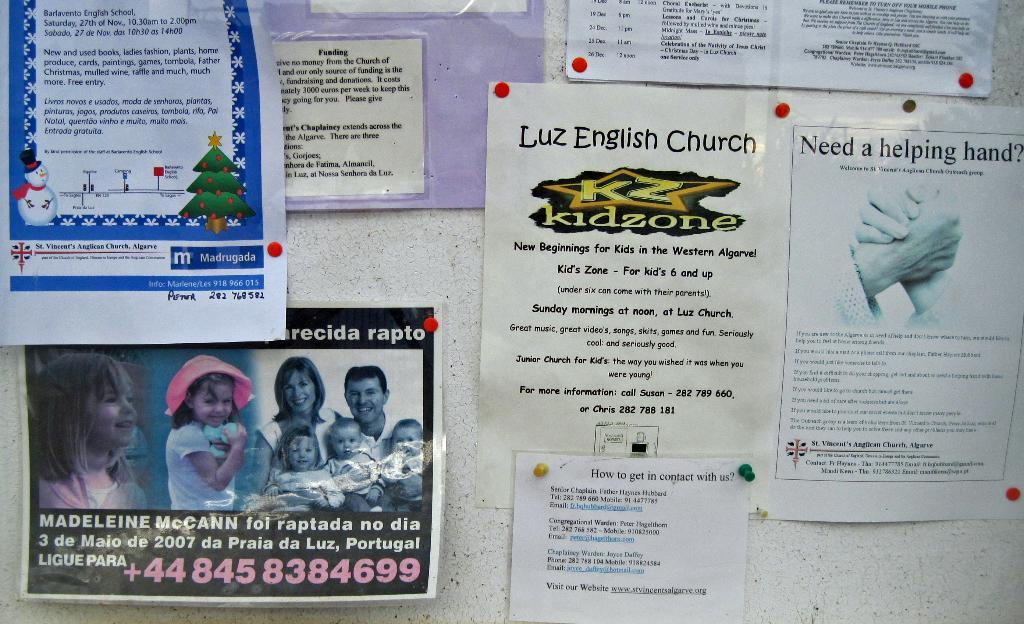<image>
Render a clear and concise summary of the photo. Papers on a wall that says "Luz English Church" on it. 